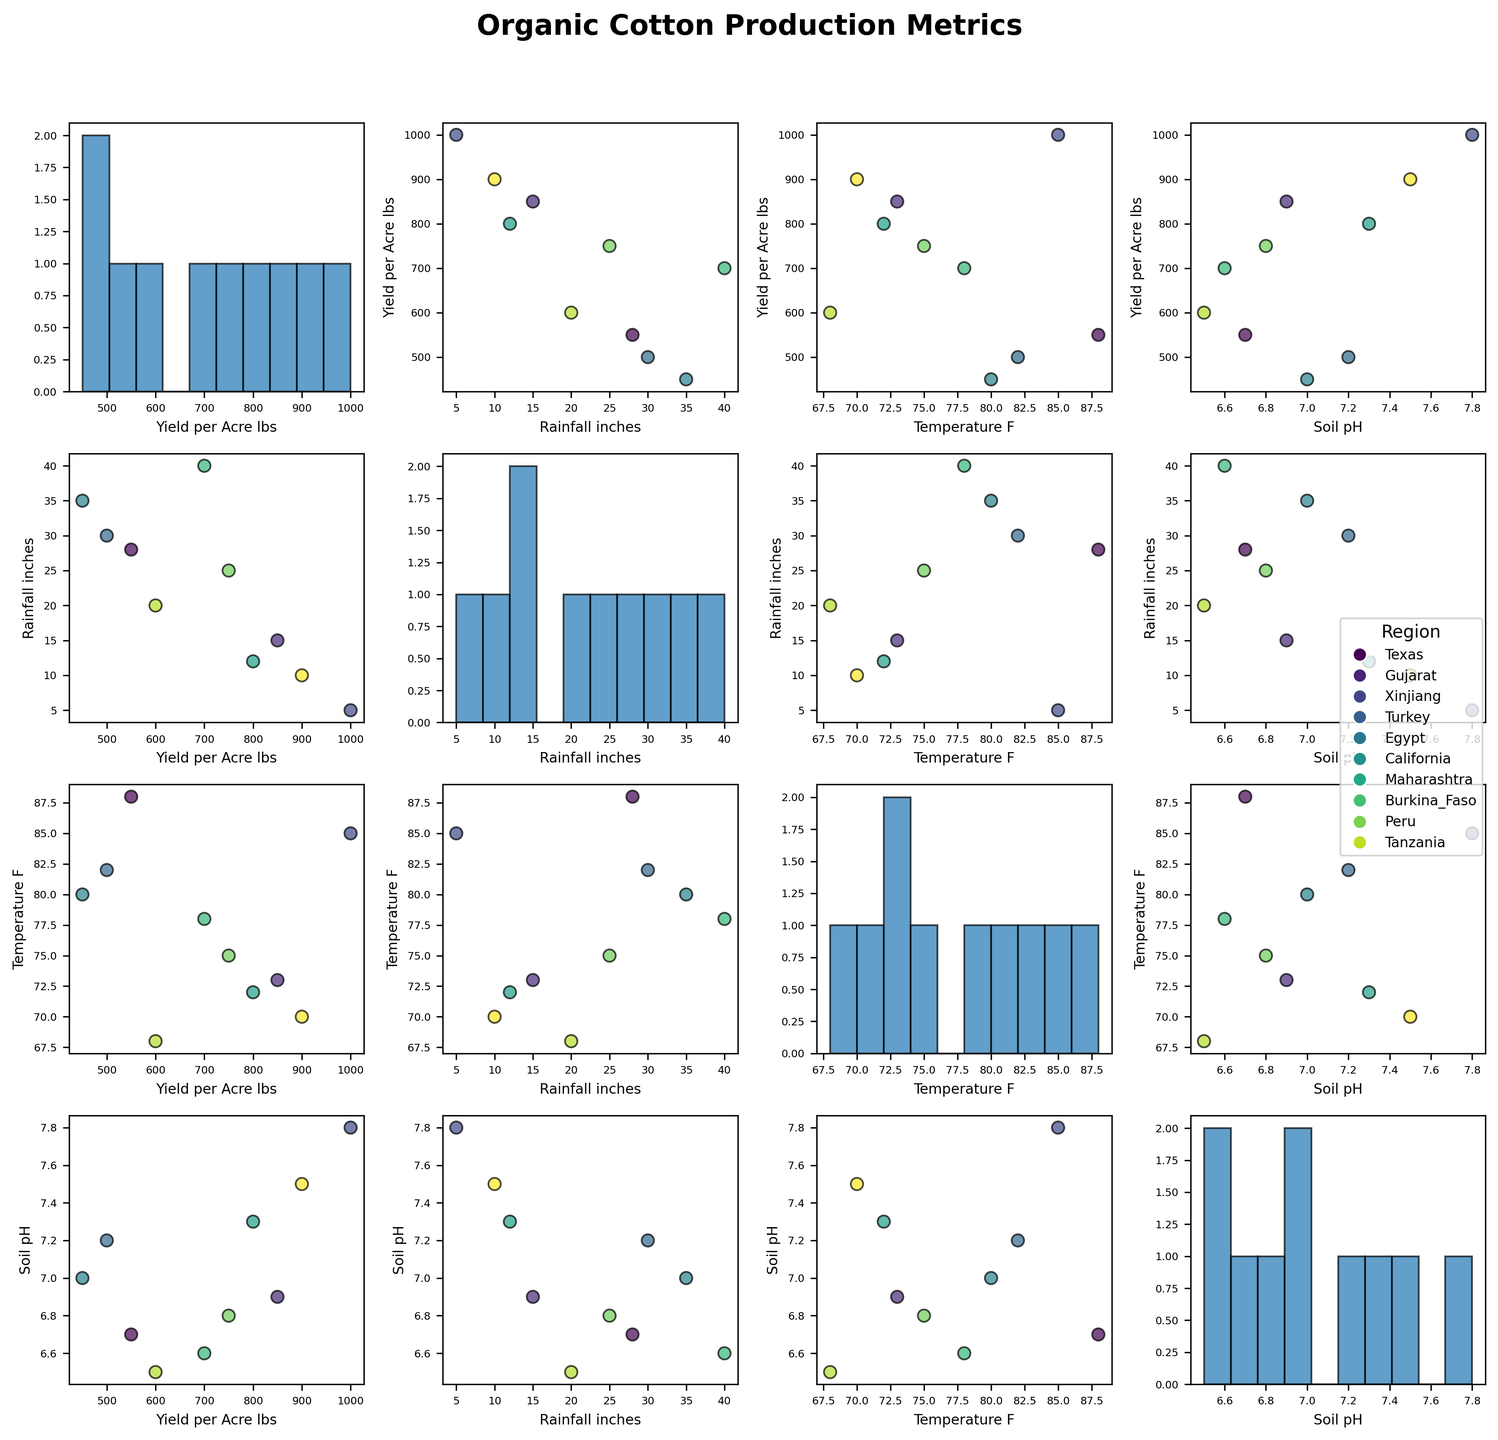What is the title of the plot? The title of the plot is usually placed at the top of the figure. Here it reads "Organic Cotton Production Metrics."
Answer: Organic Cotton Production Metrics Which variable has the highest number of bins in its histogram? The histograms are located on the diagonal of the scatterplot matrix, one for each variable. By counting the bins visually, we can determine which one has the highest number. In this case, "Yield_per_Acre_lbs" has 10 bins, making it the highest.
Answer: Yield_per_Acre_lbs What is the main color used to differentiate the regions? In the scatterplots, the points are colored using different shades of a color map. The legend indicates that the colors are derived from the 'viridis' color map, which contains shifts from yellow to green to blue.
Answer: Viridis (yellow to green to blue) How does the yield per acre correlate with temperature? To determine this, we look at the scatter plot that compares "Yield_per_Acre_lbs" on the y-axis and "Temperature_F" on the x-axis. Trends in the scatter points suggest how the two variables are related. If the points form an upward trend, there is a positive correlation; if a downward trend, a negative correlation. There is no clear trend, suggesting no strong correlation.
Answer: No strong correlation Which region has the highest yield per acre? By checking the data points in the scatter plots for "Yield_per_Acre_lbs" on the y-axis, and matching their colors to the legend, we see that Egypt has the highest yield per acre, with the point corresponding to 1000 lbs.
Answer: Egypt Is there a clear trend between soil pH and rainfall? We examine the scatter plot with "Soil_pH" on the y-axis and "Rainfall_inches" on the x-axis. By observing the scatter points, we look for any trend, either upward or downward. The scatter points are fairly dispersed, indicating no clear trend.
Answer: No clear trend What is the range of rainfall inches observed in the dataset? Looking at the scatter plots or the histogram for "Rainfall_inches," we can identify the minimum and maximum values. The rainfall ranges from approximately 5 to 40 inches.
Answer: 5 to 40 inches Which cultivation method is associated with the highest average yield per acre? By analyzing the scatter plots where "Yield_per_Acre_lbs" is on the y-axis and noting the associated cultivation methods via colors or labels, the points linked to "Conventional" cultivation methods are among the highest.
Answer: Conventional methods Is the yield generally higher in regions with higher soil pH values? To answer this, observe the scatter plots that have "Yield_per_Acre_lbs" on the y-axis and "Soil_pH" on the x-axis. Higher soil pH does not necessarily show higher yield since there is significant variability in yield across different pH levels.
Answer: No Which region has the widest range of rainfalls? We refer to the legend to match regions with points in the rainfall dimension (either x-axis in comparisons or histograms). Tanzania, with points spread across the widest rainfall range (up to around 40 inches), has the broadest range.
Answer: Tanzania 